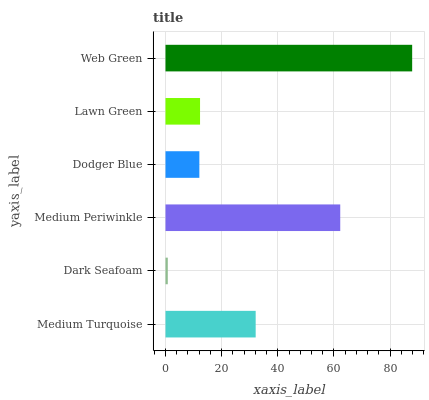Is Dark Seafoam the minimum?
Answer yes or no. Yes. Is Web Green the maximum?
Answer yes or no. Yes. Is Medium Periwinkle the minimum?
Answer yes or no. No. Is Medium Periwinkle the maximum?
Answer yes or no. No. Is Medium Periwinkle greater than Dark Seafoam?
Answer yes or no. Yes. Is Dark Seafoam less than Medium Periwinkle?
Answer yes or no. Yes. Is Dark Seafoam greater than Medium Periwinkle?
Answer yes or no. No. Is Medium Periwinkle less than Dark Seafoam?
Answer yes or no. No. Is Medium Turquoise the high median?
Answer yes or no. Yes. Is Lawn Green the low median?
Answer yes or no. Yes. Is Lawn Green the high median?
Answer yes or no. No. Is Medium Turquoise the low median?
Answer yes or no. No. 